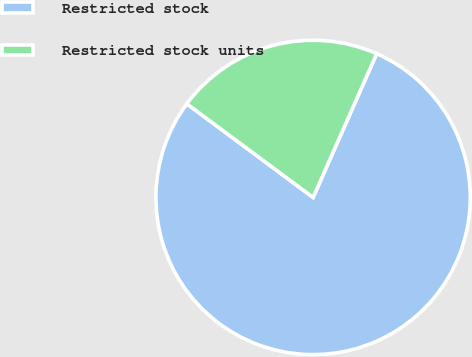Convert chart to OTSL. <chart><loc_0><loc_0><loc_500><loc_500><pie_chart><fcel>Restricted stock<fcel>Restricted stock units<nl><fcel>78.53%<fcel>21.47%<nl></chart> 